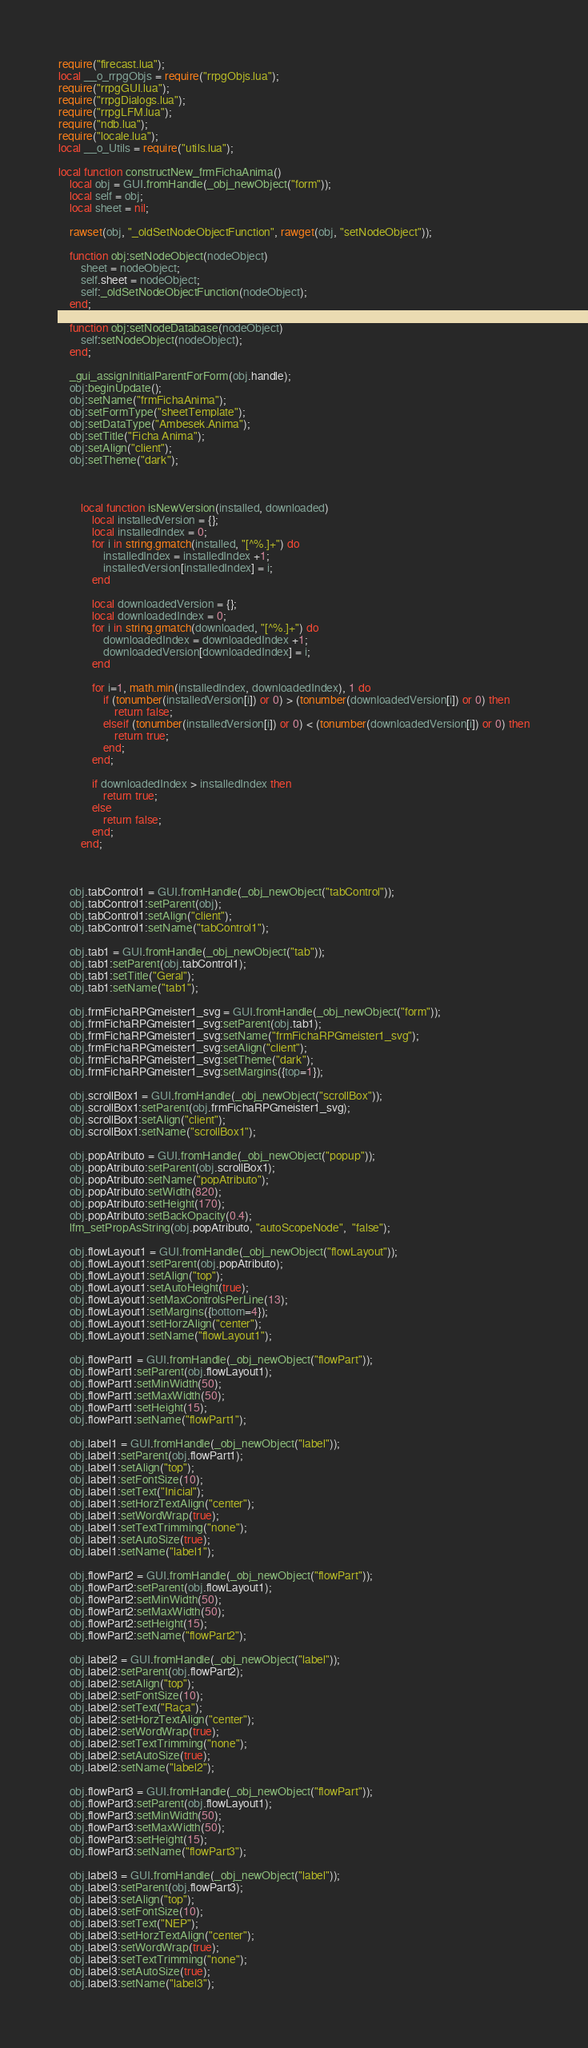<code> <loc_0><loc_0><loc_500><loc_500><_Lua_>require("firecast.lua");
local __o_rrpgObjs = require("rrpgObjs.lua");
require("rrpgGUI.lua");
require("rrpgDialogs.lua");
require("rrpgLFM.lua");
require("ndb.lua");
require("locale.lua");
local __o_Utils = require("utils.lua");

local function constructNew_frmFichaAnima()
    local obj = GUI.fromHandle(_obj_newObject("form"));
    local self = obj;
    local sheet = nil;

    rawset(obj, "_oldSetNodeObjectFunction", rawget(obj, "setNodeObject"));

    function obj:setNodeObject(nodeObject)
        sheet = nodeObject;
        self.sheet = nodeObject;
        self:_oldSetNodeObjectFunction(nodeObject);
    end;

    function obj:setNodeDatabase(nodeObject)
        self:setNodeObject(nodeObject);
    end;

    _gui_assignInitialParentForForm(obj.handle);
    obj:beginUpdate();
    obj:setName("frmFichaAnima");
    obj:setFormType("sheetTemplate");
    obj:setDataType("Ambesek.Anima");
    obj:setTitle("Ficha Anima");
    obj:setAlign("client");
    obj:setTheme("dark");



        local function isNewVersion(installed, downloaded)
            local installedVersion = {};
            local installedIndex = 0;
            for i in string.gmatch(installed, "[^%.]+") do
                installedIndex = installedIndex +1;
                installedVersion[installedIndex] = i;
            end

            local downloadedVersion = {};
            local downloadedIndex = 0;
            for i in string.gmatch(downloaded, "[^%.]+") do
                downloadedIndex = downloadedIndex +1;
                downloadedVersion[downloadedIndex] = i;
            end

            for i=1, math.min(installedIndex, downloadedIndex), 1 do 
                if (tonumber(installedVersion[i]) or 0) > (tonumber(downloadedVersion[i]) or 0) then
                    return false;
                elseif (tonumber(installedVersion[i]) or 0) < (tonumber(downloadedVersion[i]) or 0) then
                    return true;
                end;
            end;

            if downloadedIndex > installedIndex then
                return true;
            else
                return false;
            end;
        end;
        


    obj.tabControl1 = GUI.fromHandle(_obj_newObject("tabControl"));
    obj.tabControl1:setParent(obj);
    obj.tabControl1:setAlign("client");
    obj.tabControl1:setName("tabControl1");

    obj.tab1 = GUI.fromHandle(_obj_newObject("tab"));
    obj.tab1:setParent(obj.tabControl1);
    obj.tab1:setTitle("Geral");
    obj.tab1:setName("tab1");

    obj.frmFichaRPGmeister1_svg = GUI.fromHandle(_obj_newObject("form"));
    obj.frmFichaRPGmeister1_svg:setParent(obj.tab1);
    obj.frmFichaRPGmeister1_svg:setName("frmFichaRPGmeister1_svg");
    obj.frmFichaRPGmeister1_svg:setAlign("client");
    obj.frmFichaRPGmeister1_svg:setTheme("dark");
    obj.frmFichaRPGmeister1_svg:setMargins({top=1});

    obj.scrollBox1 = GUI.fromHandle(_obj_newObject("scrollBox"));
    obj.scrollBox1:setParent(obj.frmFichaRPGmeister1_svg);
    obj.scrollBox1:setAlign("client");
    obj.scrollBox1:setName("scrollBox1");

    obj.popAtributo = GUI.fromHandle(_obj_newObject("popup"));
    obj.popAtributo:setParent(obj.scrollBox1);
    obj.popAtributo:setName("popAtributo");
    obj.popAtributo:setWidth(820);
    obj.popAtributo:setHeight(170);
    obj.popAtributo:setBackOpacity(0.4);
    lfm_setPropAsString(obj.popAtributo, "autoScopeNode",  "false");

    obj.flowLayout1 = GUI.fromHandle(_obj_newObject("flowLayout"));
    obj.flowLayout1:setParent(obj.popAtributo);
    obj.flowLayout1:setAlign("top");
    obj.flowLayout1:setAutoHeight(true);
    obj.flowLayout1:setMaxControlsPerLine(13);
    obj.flowLayout1:setMargins({bottom=4});
    obj.flowLayout1:setHorzAlign("center");
    obj.flowLayout1:setName("flowLayout1");

    obj.flowPart1 = GUI.fromHandle(_obj_newObject("flowPart"));
    obj.flowPart1:setParent(obj.flowLayout1);
    obj.flowPart1:setMinWidth(50);
    obj.flowPart1:setMaxWidth(50);
    obj.flowPart1:setHeight(15);
    obj.flowPart1:setName("flowPart1");

    obj.label1 = GUI.fromHandle(_obj_newObject("label"));
    obj.label1:setParent(obj.flowPart1);
    obj.label1:setAlign("top");
    obj.label1:setFontSize(10);
    obj.label1:setText("Inicial");
    obj.label1:setHorzTextAlign("center");
    obj.label1:setWordWrap(true);
    obj.label1:setTextTrimming("none");
    obj.label1:setAutoSize(true);
    obj.label1:setName("label1");

    obj.flowPart2 = GUI.fromHandle(_obj_newObject("flowPart"));
    obj.flowPart2:setParent(obj.flowLayout1);
    obj.flowPart2:setMinWidth(50);
    obj.flowPart2:setMaxWidth(50);
    obj.flowPart2:setHeight(15);
    obj.flowPart2:setName("flowPart2");

    obj.label2 = GUI.fromHandle(_obj_newObject("label"));
    obj.label2:setParent(obj.flowPart2);
    obj.label2:setAlign("top");
    obj.label2:setFontSize(10);
    obj.label2:setText("Raça");
    obj.label2:setHorzTextAlign("center");
    obj.label2:setWordWrap(true);
    obj.label2:setTextTrimming("none");
    obj.label2:setAutoSize(true);
    obj.label2:setName("label2");

    obj.flowPart3 = GUI.fromHandle(_obj_newObject("flowPart"));
    obj.flowPart3:setParent(obj.flowLayout1);
    obj.flowPart3:setMinWidth(50);
    obj.flowPart3:setMaxWidth(50);
    obj.flowPart3:setHeight(15);
    obj.flowPart3:setName("flowPart3");

    obj.label3 = GUI.fromHandle(_obj_newObject("label"));
    obj.label3:setParent(obj.flowPart3);
    obj.label3:setAlign("top");
    obj.label3:setFontSize(10);
    obj.label3:setText("NEP");
    obj.label3:setHorzTextAlign("center");
    obj.label3:setWordWrap(true);
    obj.label3:setTextTrimming("none");
    obj.label3:setAutoSize(true);
    obj.label3:setName("label3");
</code> 